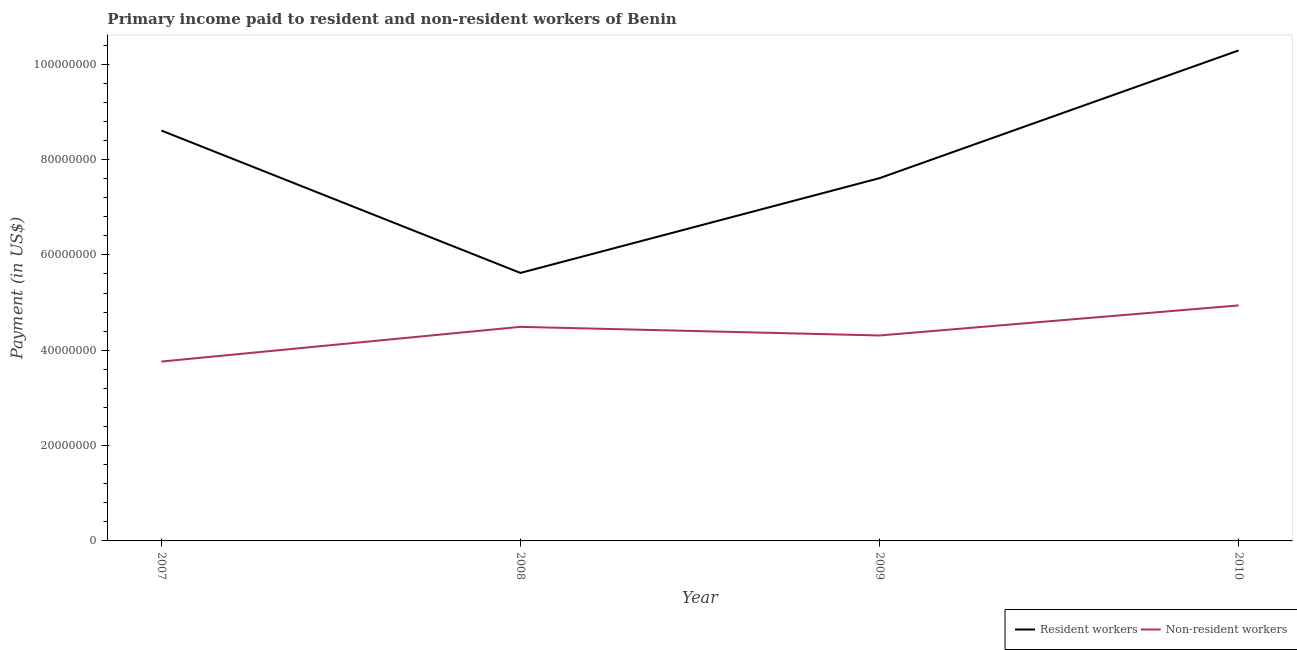What is the payment made to resident workers in 2009?
Offer a very short reply. 7.61e+07. Across all years, what is the maximum payment made to resident workers?
Offer a terse response. 1.03e+08. Across all years, what is the minimum payment made to resident workers?
Ensure brevity in your answer.  5.62e+07. In which year was the payment made to non-resident workers maximum?
Offer a very short reply. 2010. In which year was the payment made to non-resident workers minimum?
Ensure brevity in your answer.  2007. What is the total payment made to resident workers in the graph?
Keep it short and to the point. 3.21e+08. What is the difference between the payment made to non-resident workers in 2009 and that in 2010?
Provide a succinct answer. -6.30e+06. What is the difference between the payment made to resident workers in 2008 and the payment made to non-resident workers in 2009?
Your answer should be compact. 1.31e+07. What is the average payment made to resident workers per year?
Offer a terse response. 8.03e+07. In the year 2009, what is the difference between the payment made to resident workers and payment made to non-resident workers?
Offer a terse response. 3.30e+07. What is the ratio of the payment made to non-resident workers in 2008 to that in 2009?
Provide a succinct answer. 1.04. Is the difference between the payment made to non-resident workers in 2009 and 2010 greater than the difference between the payment made to resident workers in 2009 and 2010?
Make the answer very short. Yes. What is the difference between the highest and the second highest payment made to resident workers?
Make the answer very short. 1.68e+07. What is the difference between the highest and the lowest payment made to non-resident workers?
Give a very brief answer. 1.18e+07. Is the sum of the payment made to non-resident workers in 2007 and 2008 greater than the maximum payment made to resident workers across all years?
Your response must be concise. No. Does the payment made to non-resident workers monotonically increase over the years?
Make the answer very short. No. How many lines are there?
Your response must be concise. 2. Does the graph contain grids?
Give a very brief answer. No. How many legend labels are there?
Offer a terse response. 2. How are the legend labels stacked?
Keep it short and to the point. Horizontal. What is the title of the graph?
Keep it short and to the point. Primary income paid to resident and non-resident workers of Benin. What is the label or title of the Y-axis?
Keep it short and to the point. Payment (in US$). What is the Payment (in US$) of Resident workers in 2007?
Provide a short and direct response. 8.61e+07. What is the Payment (in US$) of Non-resident workers in 2007?
Offer a very short reply. 3.76e+07. What is the Payment (in US$) in Resident workers in 2008?
Your response must be concise. 5.62e+07. What is the Payment (in US$) of Non-resident workers in 2008?
Keep it short and to the point. 4.49e+07. What is the Payment (in US$) in Resident workers in 2009?
Your answer should be compact. 7.61e+07. What is the Payment (in US$) of Non-resident workers in 2009?
Your answer should be very brief. 4.31e+07. What is the Payment (in US$) in Resident workers in 2010?
Your answer should be compact. 1.03e+08. What is the Payment (in US$) of Non-resident workers in 2010?
Make the answer very short. 4.94e+07. Across all years, what is the maximum Payment (in US$) of Resident workers?
Ensure brevity in your answer.  1.03e+08. Across all years, what is the maximum Payment (in US$) of Non-resident workers?
Offer a terse response. 4.94e+07. Across all years, what is the minimum Payment (in US$) of Resident workers?
Offer a very short reply. 5.62e+07. Across all years, what is the minimum Payment (in US$) of Non-resident workers?
Offer a very short reply. 3.76e+07. What is the total Payment (in US$) of Resident workers in the graph?
Give a very brief answer. 3.21e+08. What is the total Payment (in US$) in Non-resident workers in the graph?
Provide a short and direct response. 1.75e+08. What is the difference between the Payment (in US$) in Resident workers in 2007 and that in 2008?
Your answer should be compact. 2.99e+07. What is the difference between the Payment (in US$) in Non-resident workers in 2007 and that in 2008?
Provide a succinct answer. -7.28e+06. What is the difference between the Payment (in US$) in Resident workers in 2007 and that in 2009?
Your answer should be compact. 9.99e+06. What is the difference between the Payment (in US$) of Non-resident workers in 2007 and that in 2009?
Provide a succinct answer. -5.47e+06. What is the difference between the Payment (in US$) in Resident workers in 2007 and that in 2010?
Give a very brief answer. -1.68e+07. What is the difference between the Payment (in US$) of Non-resident workers in 2007 and that in 2010?
Make the answer very short. -1.18e+07. What is the difference between the Payment (in US$) of Resident workers in 2008 and that in 2009?
Offer a very short reply. -1.99e+07. What is the difference between the Payment (in US$) in Non-resident workers in 2008 and that in 2009?
Your response must be concise. 1.81e+06. What is the difference between the Payment (in US$) of Resident workers in 2008 and that in 2010?
Your response must be concise. -4.67e+07. What is the difference between the Payment (in US$) of Non-resident workers in 2008 and that in 2010?
Provide a short and direct response. -4.49e+06. What is the difference between the Payment (in US$) of Resident workers in 2009 and that in 2010?
Give a very brief answer. -2.68e+07. What is the difference between the Payment (in US$) of Non-resident workers in 2009 and that in 2010?
Your answer should be compact. -6.30e+06. What is the difference between the Payment (in US$) of Resident workers in 2007 and the Payment (in US$) of Non-resident workers in 2008?
Your answer should be compact. 4.12e+07. What is the difference between the Payment (in US$) in Resident workers in 2007 and the Payment (in US$) in Non-resident workers in 2009?
Give a very brief answer. 4.30e+07. What is the difference between the Payment (in US$) of Resident workers in 2007 and the Payment (in US$) of Non-resident workers in 2010?
Offer a very short reply. 3.67e+07. What is the difference between the Payment (in US$) in Resident workers in 2008 and the Payment (in US$) in Non-resident workers in 2009?
Your response must be concise. 1.31e+07. What is the difference between the Payment (in US$) of Resident workers in 2008 and the Payment (in US$) of Non-resident workers in 2010?
Your response must be concise. 6.82e+06. What is the difference between the Payment (in US$) of Resident workers in 2009 and the Payment (in US$) of Non-resident workers in 2010?
Keep it short and to the point. 2.67e+07. What is the average Payment (in US$) in Resident workers per year?
Provide a succinct answer. 8.03e+07. What is the average Payment (in US$) in Non-resident workers per year?
Your answer should be compact. 4.38e+07. In the year 2007, what is the difference between the Payment (in US$) of Resident workers and Payment (in US$) of Non-resident workers?
Offer a terse response. 4.85e+07. In the year 2008, what is the difference between the Payment (in US$) in Resident workers and Payment (in US$) in Non-resident workers?
Your answer should be very brief. 1.13e+07. In the year 2009, what is the difference between the Payment (in US$) of Resident workers and Payment (in US$) of Non-resident workers?
Offer a terse response. 3.30e+07. In the year 2010, what is the difference between the Payment (in US$) of Resident workers and Payment (in US$) of Non-resident workers?
Provide a short and direct response. 5.35e+07. What is the ratio of the Payment (in US$) of Resident workers in 2007 to that in 2008?
Your answer should be compact. 1.53. What is the ratio of the Payment (in US$) in Non-resident workers in 2007 to that in 2008?
Your answer should be very brief. 0.84. What is the ratio of the Payment (in US$) of Resident workers in 2007 to that in 2009?
Offer a terse response. 1.13. What is the ratio of the Payment (in US$) of Non-resident workers in 2007 to that in 2009?
Your answer should be very brief. 0.87. What is the ratio of the Payment (in US$) of Resident workers in 2007 to that in 2010?
Provide a short and direct response. 0.84. What is the ratio of the Payment (in US$) of Non-resident workers in 2007 to that in 2010?
Your answer should be very brief. 0.76. What is the ratio of the Payment (in US$) in Resident workers in 2008 to that in 2009?
Your response must be concise. 0.74. What is the ratio of the Payment (in US$) in Non-resident workers in 2008 to that in 2009?
Ensure brevity in your answer.  1.04. What is the ratio of the Payment (in US$) in Resident workers in 2008 to that in 2010?
Make the answer very short. 0.55. What is the ratio of the Payment (in US$) of Non-resident workers in 2008 to that in 2010?
Provide a succinct answer. 0.91. What is the ratio of the Payment (in US$) in Resident workers in 2009 to that in 2010?
Ensure brevity in your answer.  0.74. What is the ratio of the Payment (in US$) in Non-resident workers in 2009 to that in 2010?
Keep it short and to the point. 0.87. What is the difference between the highest and the second highest Payment (in US$) in Resident workers?
Offer a terse response. 1.68e+07. What is the difference between the highest and the second highest Payment (in US$) of Non-resident workers?
Make the answer very short. 4.49e+06. What is the difference between the highest and the lowest Payment (in US$) in Resident workers?
Make the answer very short. 4.67e+07. What is the difference between the highest and the lowest Payment (in US$) of Non-resident workers?
Keep it short and to the point. 1.18e+07. 